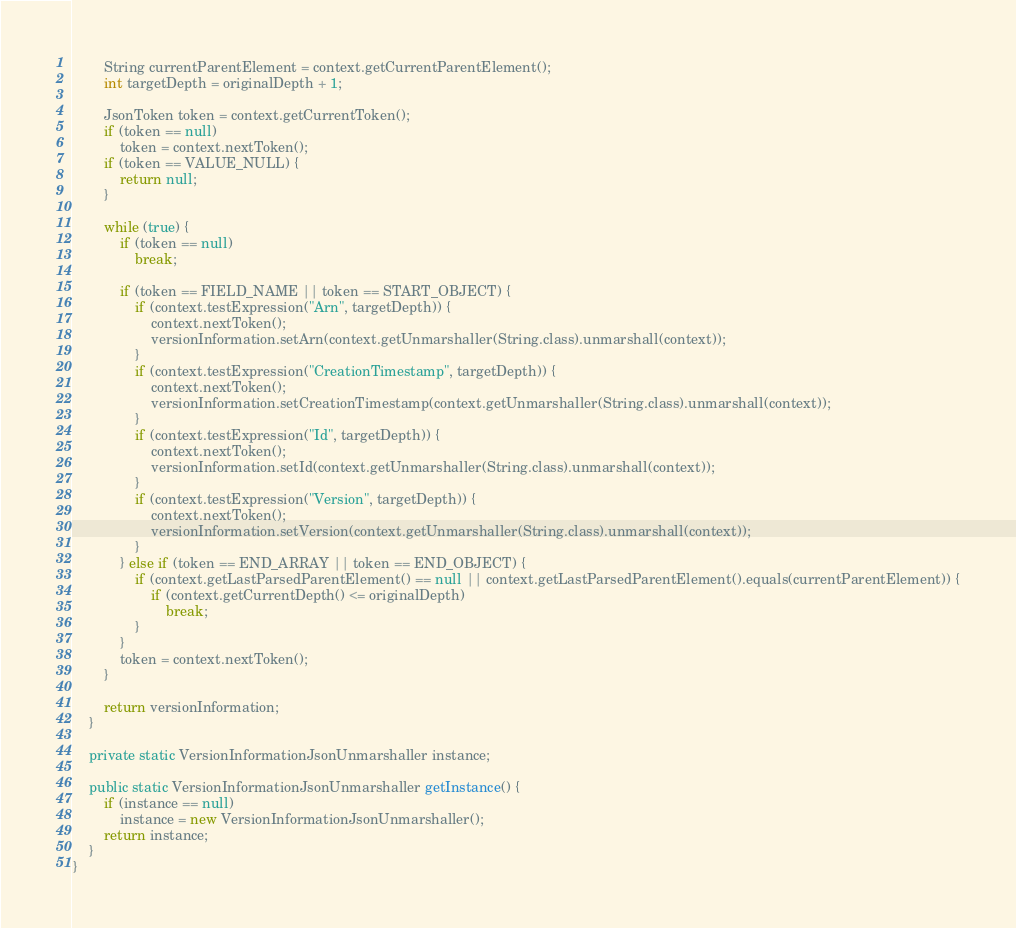<code> <loc_0><loc_0><loc_500><loc_500><_Java_>        String currentParentElement = context.getCurrentParentElement();
        int targetDepth = originalDepth + 1;

        JsonToken token = context.getCurrentToken();
        if (token == null)
            token = context.nextToken();
        if (token == VALUE_NULL) {
            return null;
        }

        while (true) {
            if (token == null)
                break;

            if (token == FIELD_NAME || token == START_OBJECT) {
                if (context.testExpression("Arn", targetDepth)) {
                    context.nextToken();
                    versionInformation.setArn(context.getUnmarshaller(String.class).unmarshall(context));
                }
                if (context.testExpression("CreationTimestamp", targetDepth)) {
                    context.nextToken();
                    versionInformation.setCreationTimestamp(context.getUnmarshaller(String.class).unmarshall(context));
                }
                if (context.testExpression("Id", targetDepth)) {
                    context.nextToken();
                    versionInformation.setId(context.getUnmarshaller(String.class).unmarshall(context));
                }
                if (context.testExpression("Version", targetDepth)) {
                    context.nextToken();
                    versionInformation.setVersion(context.getUnmarshaller(String.class).unmarshall(context));
                }
            } else if (token == END_ARRAY || token == END_OBJECT) {
                if (context.getLastParsedParentElement() == null || context.getLastParsedParentElement().equals(currentParentElement)) {
                    if (context.getCurrentDepth() <= originalDepth)
                        break;
                }
            }
            token = context.nextToken();
        }

        return versionInformation;
    }

    private static VersionInformationJsonUnmarshaller instance;

    public static VersionInformationJsonUnmarshaller getInstance() {
        if (instance == null)
            instance = new VersionInformationJsonUnmarshaller();
        return instance;
    }
}
</code> 